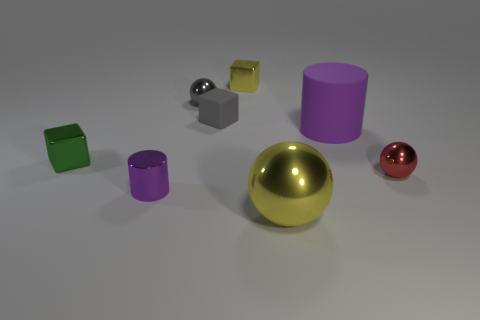There is a small green shiny object in front of the small rubber object; does it have the same shape as the yellow thing that is behind the gray rubber cube?
Offer a very short reply. Yes. Is the number of tiny purple objects that are on the right side of the small gray shiny thing the same as the number of large objects that are behind the tiny red shiny ball?
Give a very brief answer. No. There is a matte object that is right of the shiny cube that is to the right of the tiny ball that is left of the small rubber thing; what shape is it?
Make the answer very short. Cylinder. Does the green object in front of the small yellow metallic cube have the same material as the big purple thing in front of the small gray block?
Provide a succinct answer. No. What shape is the large thing left of the big rubber cylinder?
Ensure brevity in your answer.  Sphere. Is the number of small matte things less than the number of tiny blocks?
Your response must be concise. Yes. Are there any small shiny objects that are to the left of the small metal object that is on the right side of the yellow metallic thing that is behind the large matte object?
Your response must be concise. Yes. How many shiny things are tiny spheres or gray blocks?
Provide a short and direct response. 2. Does the large cylinder have the same color as the small cylinder?
Your answer should be compact. Yes. There is a large yellow ball; what number of green things are on the right side of it?
Make the answer very short. 0. 